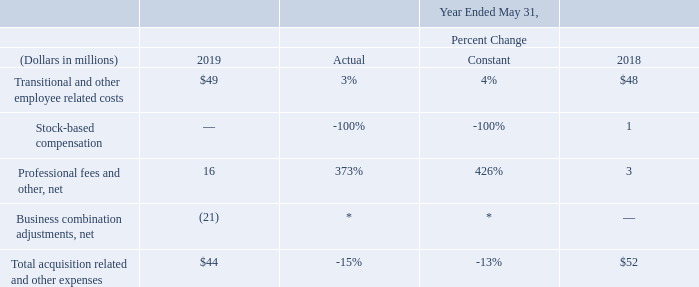Acquisition Related and Other Expenses: Acquisition related and other expenses consist of personnel related costs and stock-based compensation for transitional and certain other employees, integration related professional services, and certain business combination adjustments including certain adjustments after the measurement period has ended and certain other operating items, net. Stock-based compensation expenses included in acquisition related and other expenses resulted from unvested restricted stock-based awards and stock options assumed from acquisitions whereby vesting was accelerated generally upon termination of the employees pursuant to the original terms of those restricted stock-based awards and stock options.
* Not meaningful
On a constant currency basis, acquisition related and other expenses decreased in fiscal 2019 compared to fiscal 2018 primarily due to certain favorable business combination related adjustments that were recorded in fiscal 201 9 .
How much was the average total acquisition related and other expenses in 2018 and 2019?
Answer scale should be: million. (44+52) / 2 
Answer: 48. What was the difference between the transitional and other employee related costs in 2019 and 2018?
Answer scale should be: million. 49-48 
Answer: 1. What was the total amount spent on transitional and other employee related costs and professional fees and other, net in 2019?
Answer scale should be: million. 49 + 16 
Answer: 65. What is included in stock-based compensation expenses? Stock-based compensation expenses included in acquisition related and other expenses resulted from unvested restricted stock-based awards and stock options assumed from acquisitions whereby vesting was accelerated generally upon termination of the employees pursuant to the original terms of those restricted stock-based awards and stock options. How much was the actual and constant percentage change in professional fees and other, net?
Answer scale should be: percent. 373%, 426%. Why did acquisition related and other expenses decrease in fiscal 2019 compared to fiscal 2018? Acquisition related and other expenses decreased in fiscal 2019 compared to fiscal 2018 primarily due to certain favorable business combination related adjustments that were recorded in fiscal 201 9 . 